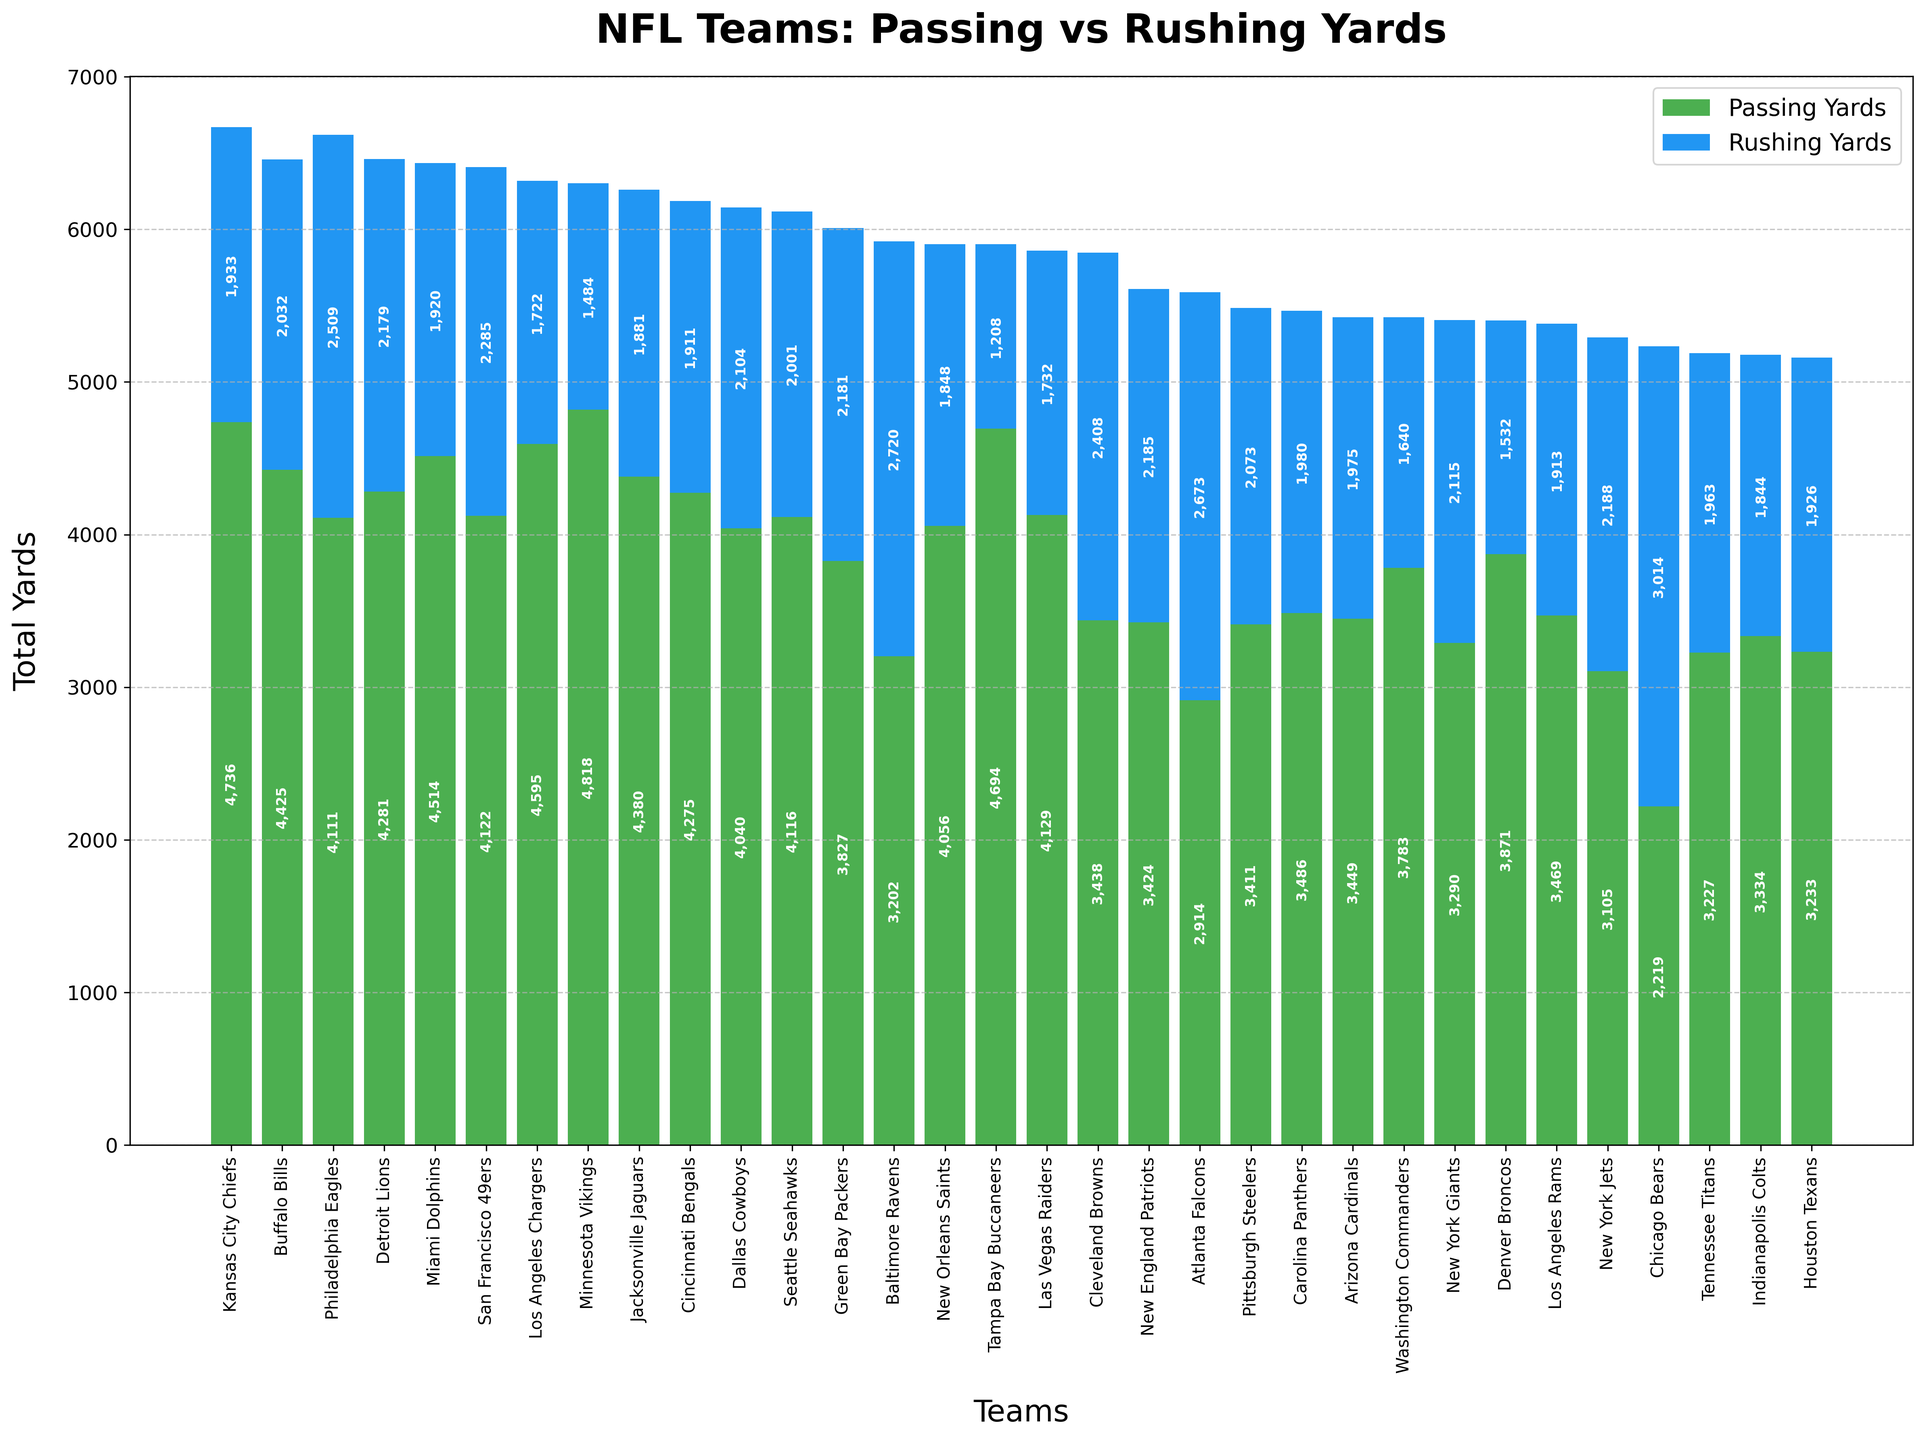Which team has the highest total offensive yards? To find the team with the highest total offensive yards, sum the passing and rushing yards for each team and compare the totals. The Philadelphia Eagles have 4111 passing yards and 2509 rushing yards, summing up to 6620 total yards. No team surpasses this total.
Answer: Philadelphia Eagles Which team has the least rushing yards? Look for the team with the shortest blue bar representing rushing yards. The Tampa Bay Buccaneers have the shortest blue bar with 1208 rushing yards.
Answer: Tampa Bay Buccaneers How do the total yards for the Kansas City Chiefs compare to the Buffalo Bills? Sum the passing and rushing yards for both teams. The Kansas City Chiefs have 4736 (passing) + 1933 (rushing) = 6669 total yards. The Buffalo Bills have 4425 (passing) + 2032 (rushing) = 6457 total yards. The Kansas City Chiefs have more total yards.
Answer: Kansas City Chiefs have more total yards Which team has more rushing yards, the Chicago Bears or the Baltimore Ravens? Compare the rushing yards directly by observing the height of the blue bars. The Chicago Bears have 3014 rushing yards, and the Baltimore Ravens have 2720 rushing yards. The Bears have more rushing yards.
Answer: Chicago Bears What is the combined total offensive yards for the Dallas Cowboys and the Seattle Seahawks? Sum the passing and rushing yards for both teams and then add these results. Dallas Cowboys: 4040 (passing) + 2104 (rushing) = 6144 total yards. Seattle Seahawks: 4116 (passing) + 2001 (rushing) = 6117 total yards. Combined total: 6144 + 6117 = 12261 total yards.
Answer: 12261 total yards Is the New York Jets' passing yards higher or lower than their rushing yards? Compare the heights of the green and blue bars for the New York Jets. They have 3105 passing yards and 2188 rushing yards, so their passing yards are higher.
Answer: Passing yards are higher Which team has the highest passing yards, and how many yards is that? Identify the team with the tallest green bar. The Minnesota Vikings have the tallest with 4818 passing yards.
Answer: Minnesota Vikings, 4818 yards How much more total yards do the Miami Dolphins have than the Las Vegas Raiders? Calculate the total yards for both teams and then find the difference. Miami Dolphins: 4514 (passing) + 1920 (rushing) = 6434 total yards. Las Vegas Raiders: 4129 (passing) + 1732 (rushing) = 5861 total yards. Difference: 6434 - 5861 = 573 yards.
Answer: 573 yards more Are there more teams with over 4000 passing yards or over 2000 rushing yards? Count the teams that meet the criteria for passing yards (>4000) and rushing yards (>2000). Passing yards: 12 teams (Kansas City Chiefs, Buffalo Bills, Miami Dolphins, Los Angeles Chargers, Minnesota Vikings, Jacksonville Jaguars, Cincinnati Bengals, Detroit Lions, Dallas Cowboys, Miami Dolphins, Tampa Bay Buccaneers, Las Vegas Raiders).  Rushing yards: 8 teams (Philadelphia Eagles, Baltimore Ravens, Cleveland Browns, Atlanta Falcons, Chicago Bears, New York Giants, Seattle Seahawks, Dallas Cowboys). There are more teams with over 4000 passing yards.
Answer: More teams with over 4000 passing yards What is the average rushing yards of NFC East teams? Identify NFC East teams (Philadelphia Eagles, Dallas Cowboys, New York Giants, Washington Commanders). Sum their rushing yards and divide by the number of teams. Eagles: 2509, Cowboys: 2104, Giants: 2115, Commanders: 1640. Total yards: 2509 + 2104 + 2115 + 1640 = 8368. Average: 8368/4 = 2092 yards.
Answer: 2092 yards 